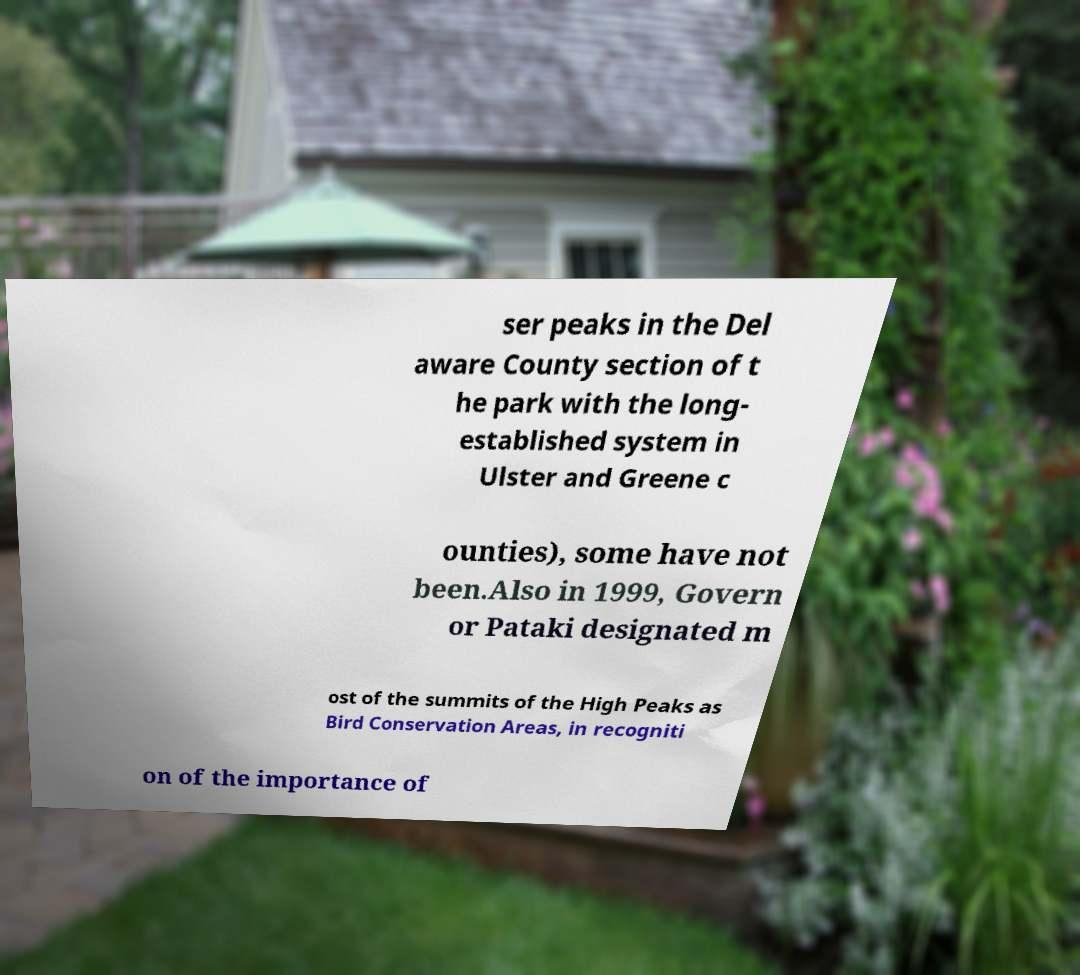Could you extract and type out the text from this image? ser peaks in the Del aware County section of t he park with the long- established system in Ulster and Greene c ounties), some have not been.Also in 1999, Govern or Pataki designated m ost of the summits of the High Peaks as Bird Conservation Areas, in recogniti on of the importance of 